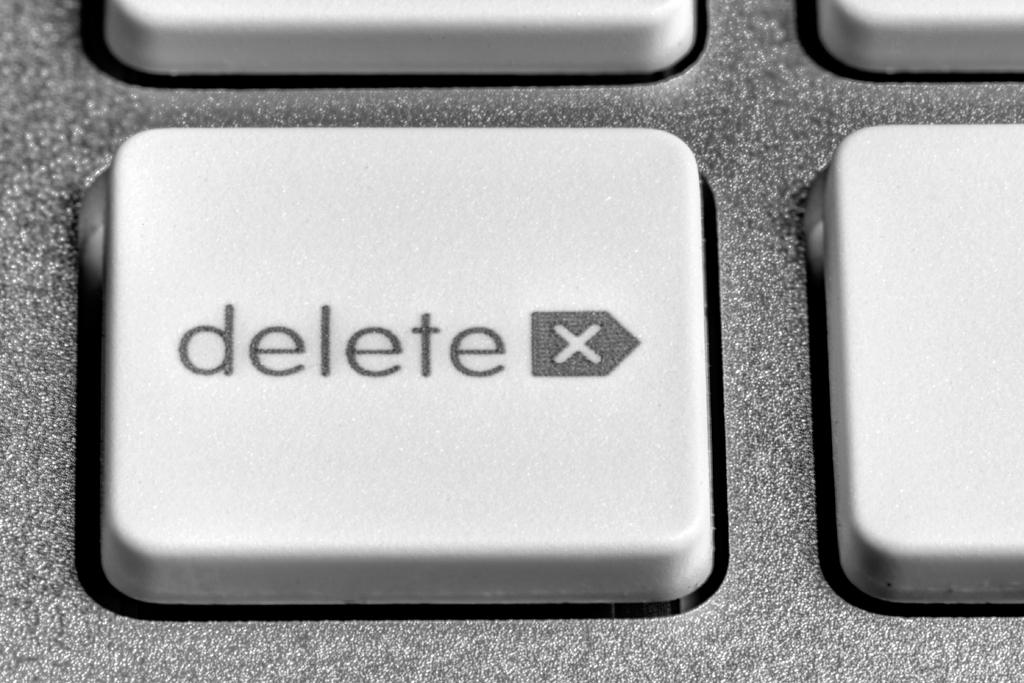What is the button on the keyboard?
Your answer should be very brief. Delete. What does the button say?
Your response must be concise. Delete. 